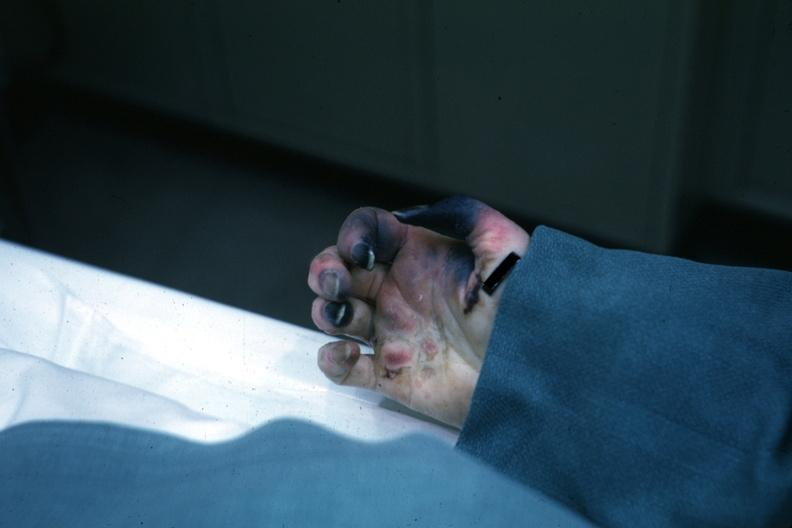s peritoneal fluid present?
Answer the question using a single word or phrase. No 